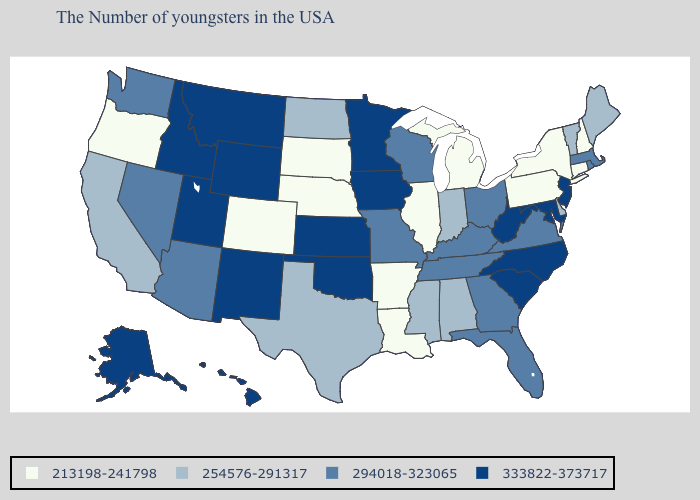Which states have the lowest value in the USA?
Short answer required. New Hampshire, Connecticut, New York, Pennsylvania, Michigan, Illinois, Louisiana, Arkansas, Nebraska, South Dakota, Colorado, Oregon. What is the lowest value in the South?
Answer briefly. 213198-241798. What is the value of New Hampshire?
Answer briefly. 213198-241798. Name the states that have a value in the range 333822-373717?
Answer briefly. New Jersey, Maryland, North Carolina, South Carolina, West Virginia, Minnesota, Iowa, Kansas, Oklahoma, Wyoming, New Mexico, Utah, Montana, Idaho, Alaska, Hawaii. What is the value of Michigan?
Answer briefly. 213198-241798. What is the value of Wisconsin?
Be succinct. 294018-323065. Which states have the lowest value in the USA?
Give a very brief answer. New Hampshire, Connecticut, New York, Pennsylvania, Michigan, Illinois, Louisiana, Arkansas, Nebraska, South Dakota, Colorado, Oregon. What is the value of Texas?
Concise answer only. 254576-291317. Name the states that have a value in the range 333822-373717?
Write a very short answer. New Jersey, Maryland, North Carolina, South Carolina, West Virginia, Minnesota, Iowa, Kansas, Oklahoma, Wyoming, New Mexico, Utah, Montana, Idaho, Alaska, Hawaii. Which states have the lowest value in the USA?
Keep it brief. New Hampshire, Connecticut, New York, Pennsylvania, Michigan, Illinois, Louisiana, Arkansas, Nebraska, South Dakota, Colorado, Oregon. Name the states that have a value in the range 213198-241798?
Keep it brief. New Hampshire, Connecticut, New York, Pennsylvania, Michigan, Illinois, Louisiana, Arkansas, Nebraska, South Dakota, Colorado, Oregon. Name the states that have a value in the range 213198-241798?
Concise answer only. New Hampshire, Connecticut, New York, Pennsylvania, Michigan, Illinois, Louisiana, Arkansas, Nebraska, South Dakota, Colorado, Oregon. Does Illinois have the same value as Kansas?
Give a very brief answer. No. What is the lowest value in the USA?
Give a very brief answer. 213198-241798. 